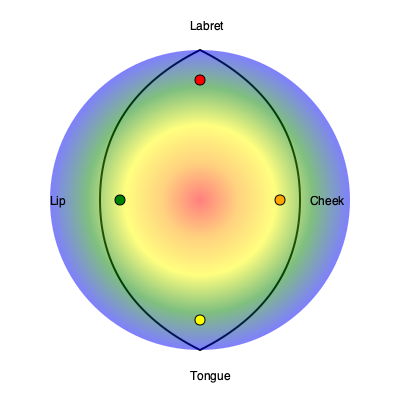Based on the heat map overlay on the dental diagram, which oral piercing location is associated with the highest risk of dental fractures, and what factor primarily contributes to this increased risk? 1. Interpret the heat map:
   - Red indicates the highest risk, followed by orange, yellow, green, and blue.
   - The center of the heat map (red area) corresponds to the front teeth.

2. Analyze piercing locations:
   - Labret (center top): Located in the red zone, indicating highest risk.
   - Cheek (right): Located in the orange zone, indicating high risk.
   - Tongue (center bottom): Located in the yellow zone, indicating moderate risk.
   - Lip (left): Located in the green zone, indicating lower risk.

3. Consider anatomical factors:
   - Labret piercings are closest to the front teeth (incisors and canines).
   - Front teeth are more susceptible to fractures due to their shape and position.

4. Evaluate mechanical stress:
   - Labret jewelry constantly contacts the back of front teeth during speaking and eating.
   - This repeated contact can cause enamel erosion and microfractures over time.

5. Consider jewelry material and movement:
   - Metal jewelry is harder than tooth enamel.
   - Labret studs have limited movement, concentrating force on specific tooth areas.

6. Compare to other locations:
   - Cheek and lip piercings mainly affect molars, which are more resistant to fractures.
   - Tongue piercings can cause damage but have more space to move, dispersing force.

Therefore, the labret piercing location is associated with the highest risk of dental fractures, primarily due to its proximity to vulnerable front teeth and constant mechanical stress on these teeth during daily activities.
Answer: Labret; proximity to front teeth and constant mechanical stress 